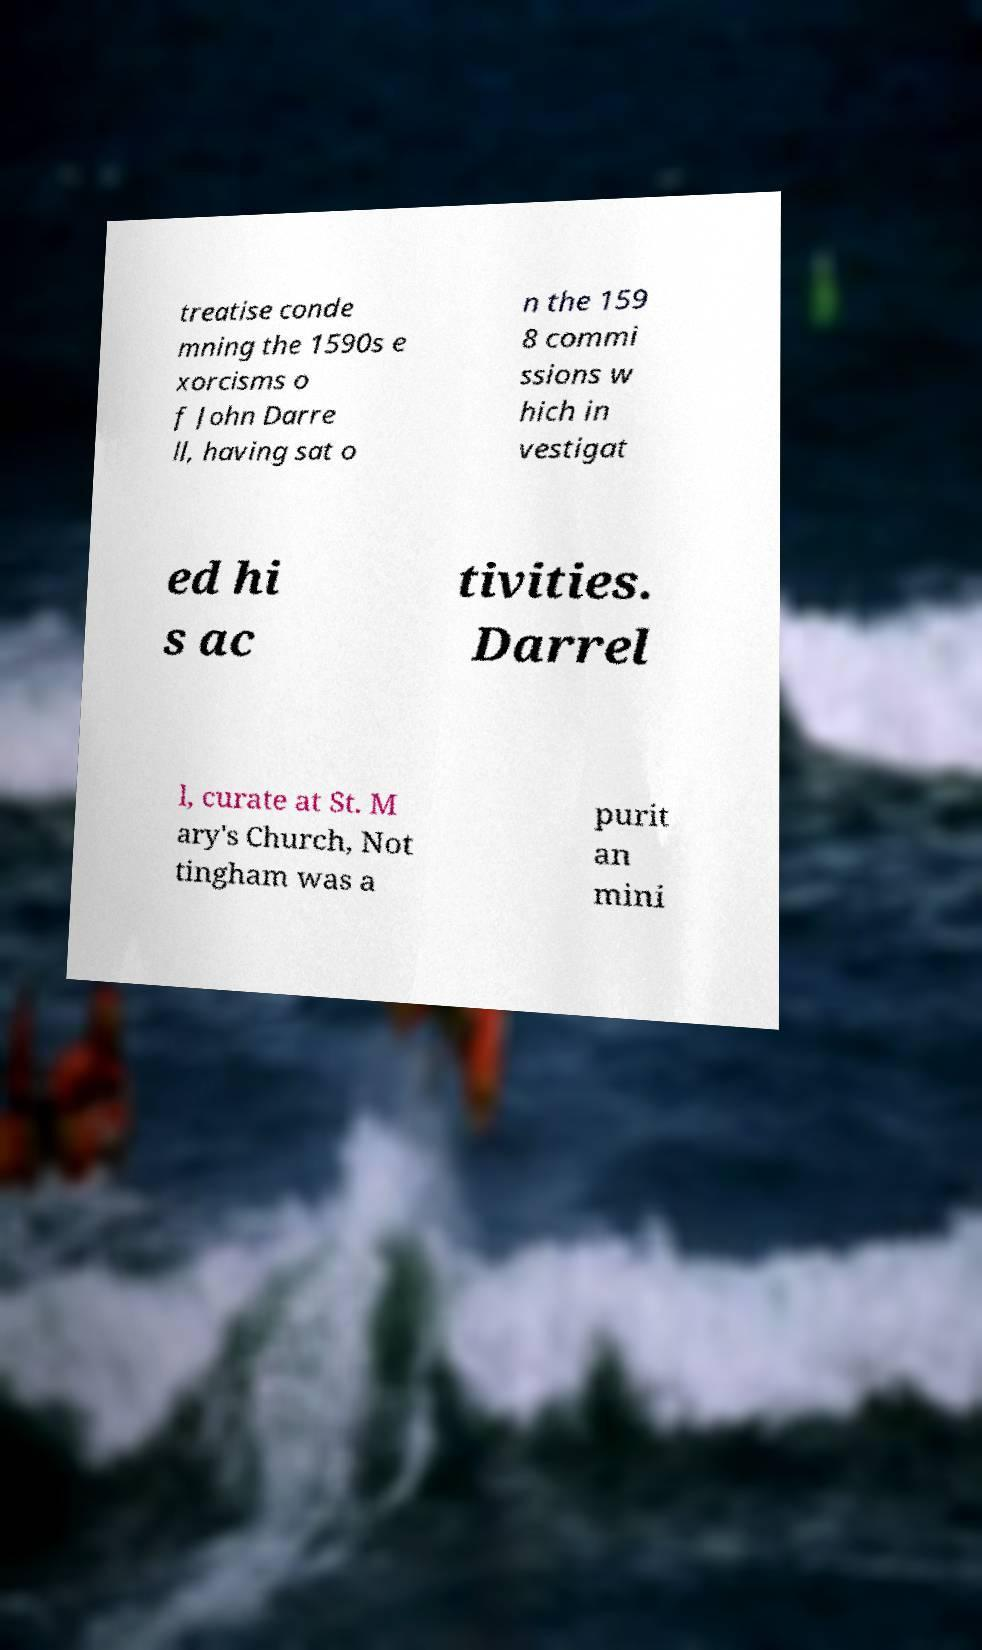Could you assist in decoding the text presented in this image and type it out clearly? treatise conde mning the 1590s e xorcisms o f John Darre ll, having sat o n the 159 8 commi ssions w hich in vestigat ed hi s ac tivities. Darrel l, curate at St. M ary's Church, Not tingham was a purit an mini 